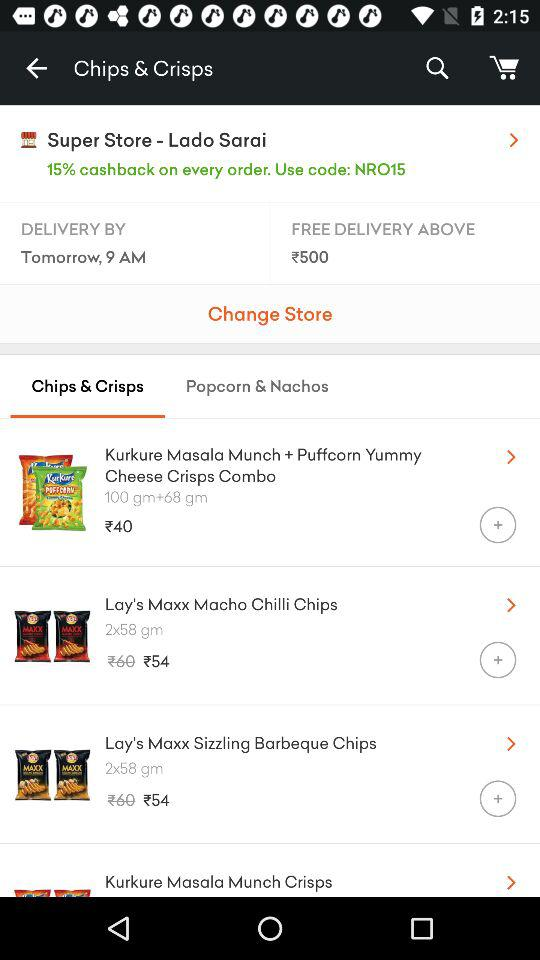What's the price of Lay's Maxx Macho Chilli Chips? The price is ₹54. 